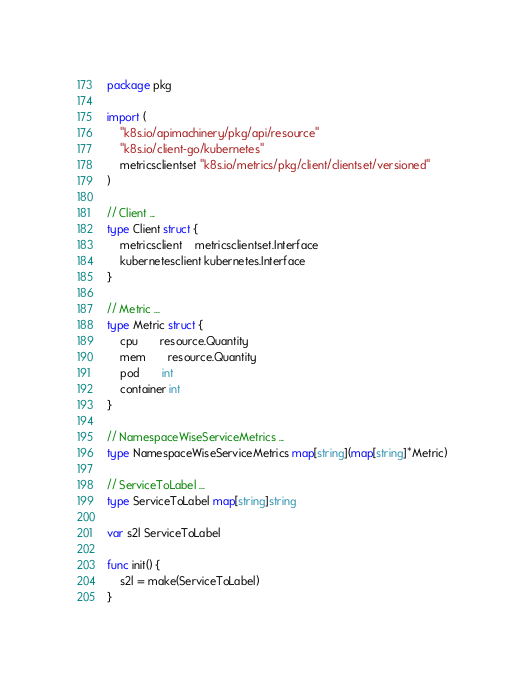Convert code to text. <code><loc_0><loc_0><loc_500><loc_500><_Go_>package pkg

import (
	"k8s.io/apimachinery/pkg/api/resource"
	"k8s.io/client-go/kubernetes"
	metricsclientset "k8s.io/metrics/pkg/client/clientset/versioned"
)

// Client ...
type Client struct {
	metricsclient    metricsclientset.Interface
	kubernetesclient kubernetes.Interface
}

// Metric ...
type Metric struct {
	cpu       resource.Quantity
	mem       resource.Quantity
	pod       int
	container int
}

// NamespaceWiseServiceMetrics ...
type NamespaceWiseServiceMetrics map[string](map[string]*Metric)

// ServiceToLabel ...
type ServiceToLabel map[string]string

var s2l ServiceToLabel

func init() {
	s2l = make(ServiceToLabel)
}
</code> 